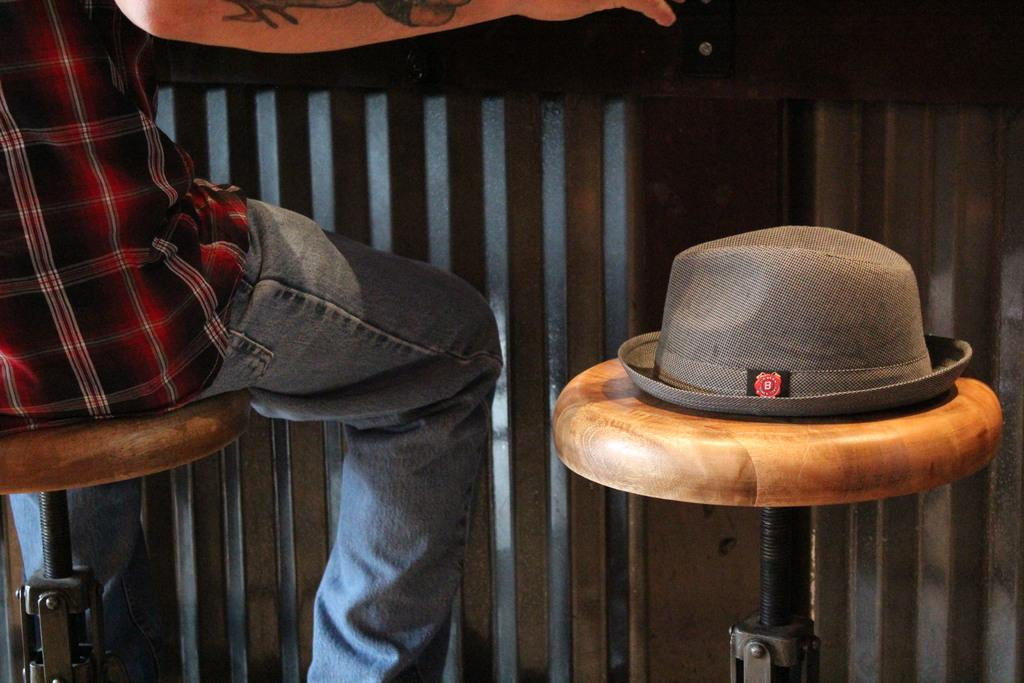What is the person in the image doing? The person is sitting on a seating stool in the image. What else can be seen on a seating stool in the image? There is a hat on another seating stool in the image. What type of hose is being used by the beast in the image? There is no beast or hose present in the image. 